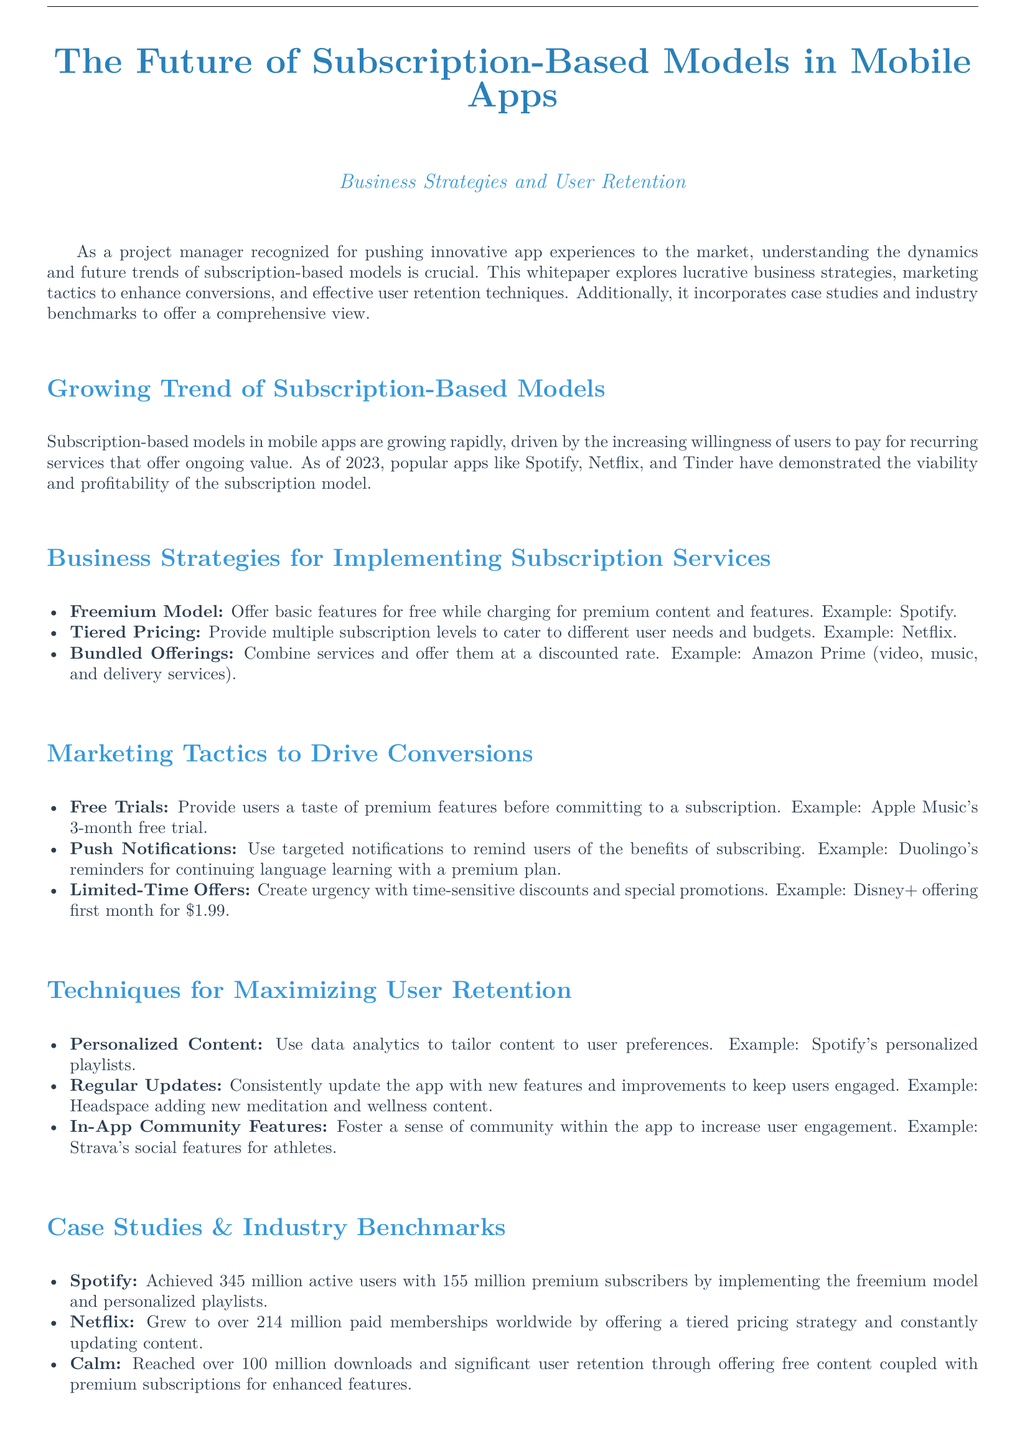What are the popular apps mentioned that use subscription models? The document mentions popular apps like Spotify, Netflix, and Tinder as examples of subscription-based models.
Answer: Spotify, Netflix, Tinder What is one business strategy for implementing subscription services? One of the business strategies listed for implementing subscription services is the Freemium Model.
Answer: Freemium Model How many active users does Spotify have? According to the document, Spotify achieved 345 million active users.
Answer: 345 million What marketing tactic involves reminding users of subscription benefits? The tactic that involves reminding users is Push Notifications.
Answer: Push Notifications What is the tiered pricing strategy used by? The document provides Netflix as an example of using a tiered pricing strategy.
Answer: Netflix What technique is used to maximize user retention through personalization? The technique associated with user retention through personalization is Personalized Content.
Answer: Personalized Content How many premium subscribers does Spotify have? The document states that Spotify has 155 million premium subscribers.
Answer: 155 million Which app grew to 214 million paid memberships? The app that grew to 214 million paid memberships is Netflix.
Answer: Netflix What does Calm combine to enhance user retention? Calm combines free content with premium subscriptions to enhance user retention.
Answer: Free content with premium subscriptions 